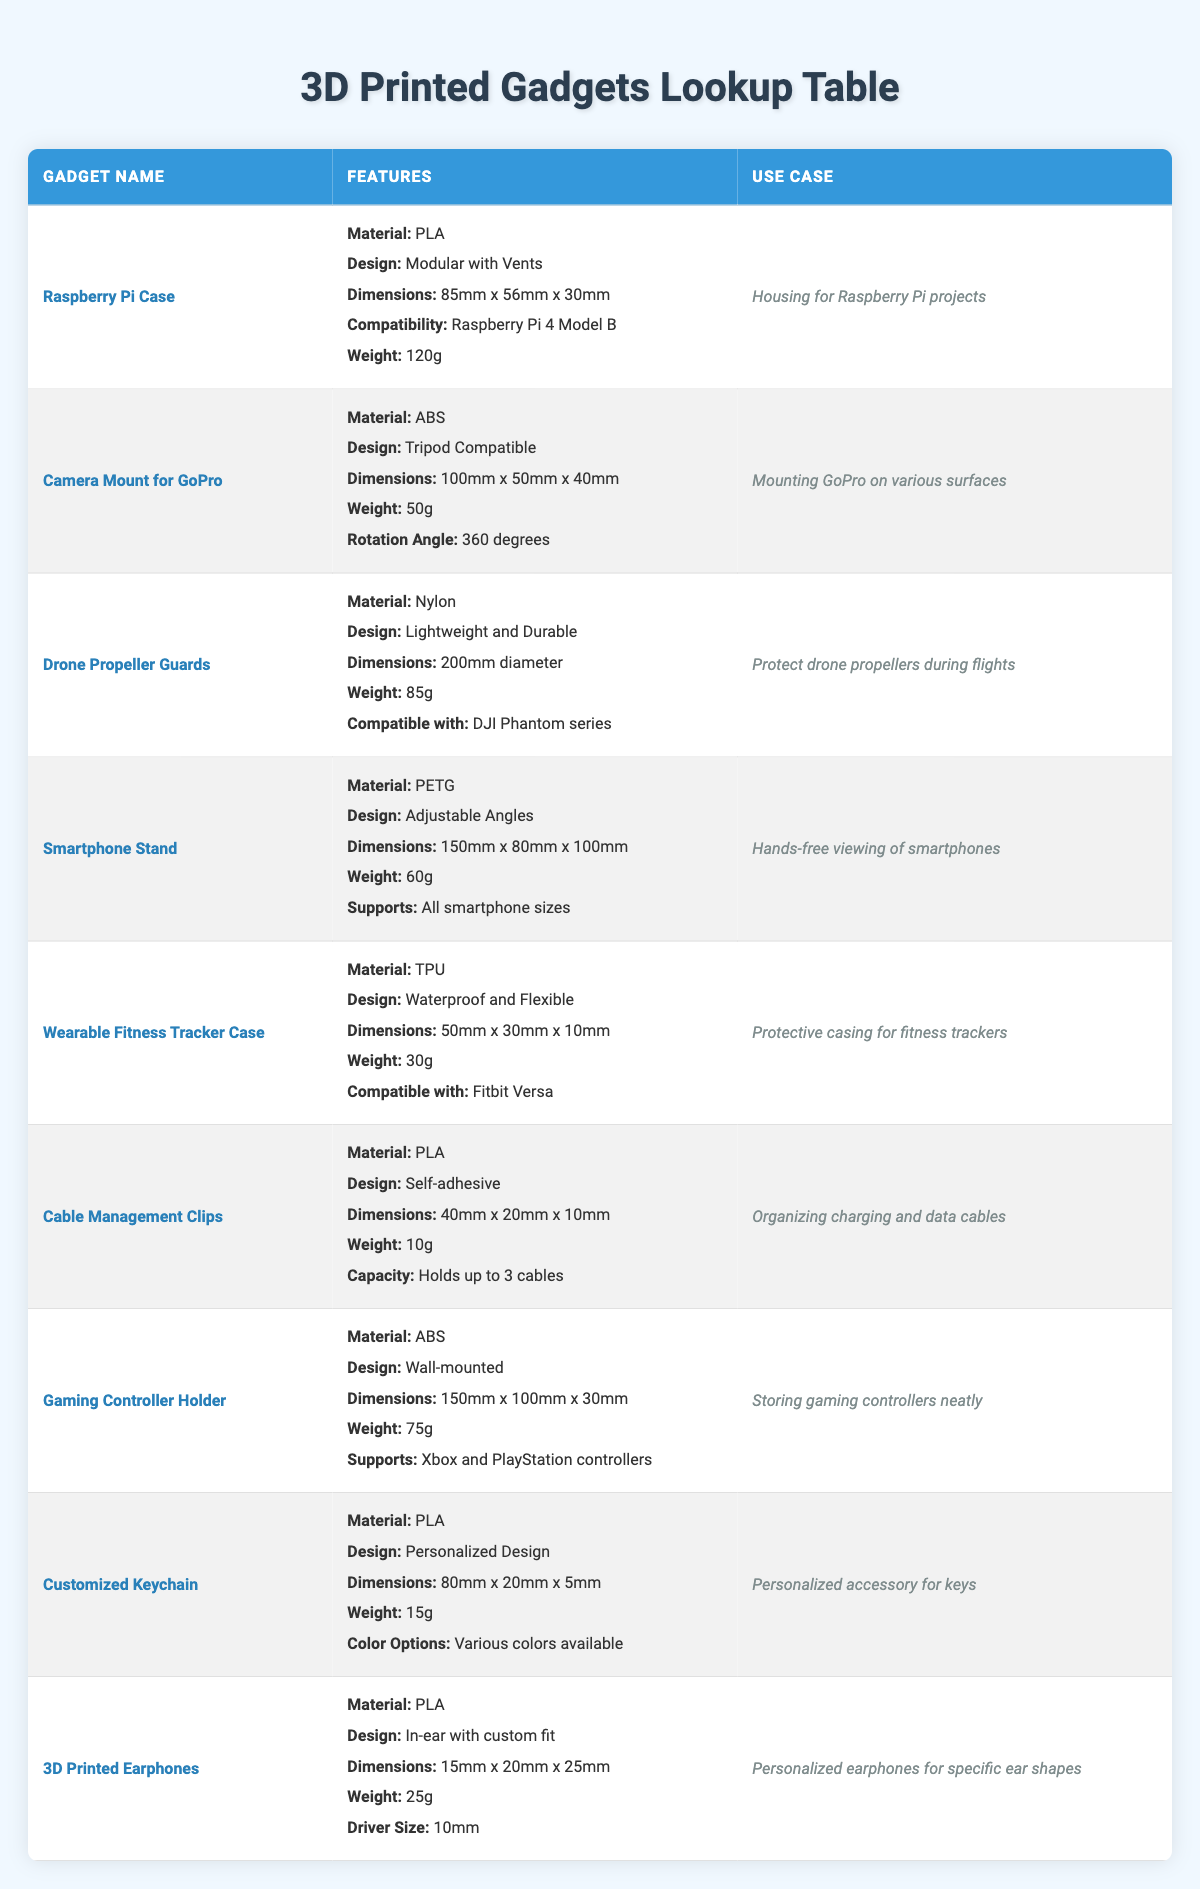What is the material used in the Raspberry Pi Case? The table indicates that the Raspberry Pi Case is made from PLA.
Answer: PLA How much does the Smartphone Stand weigh? Based on the table, the weight of the Smartphone Stand is given as 60g.
Answer: 60g Is the Gaming Controller Holder compatible with PlayStation controllers? Yes, the table shows that the Gaming Controller Holder supports Xbox and PlayStation controllers, confirming compatibility.
Answer: Yes What is the difference in weight between the Cable Management Clips and the Wearable Fitness Tracker Case? The weight of the Cable Management Clips is 10g, and the weight of the Wearable Fitness Tracker Case is 30g. The difference is 30g - 10g = 20g.
Answer: 20g Which gadget is designed for hands-free viewing of smartphones? According to the table, the Smartphone Stand specifically mentions its use case as hands-free viewing of smartphones.
Answer: Smartphone Stand What is the combined weight of the 3D Printed Earphones and Camera Mount for GoPro? The weight of the 3D Printed Earphones is 25g, and the Camera Mount for GoPro weighs 50g. Therefore, the combined weight is 25g + 50g = 75g.
Answer: 75g Does the Drone Propeller Guards have adjustable design features? No, the features listed for the Drone Propeller Guards do not mention adjustable design; instead, it is noted as lightweight and durable.
Answer: No What is the maximum cable capacity of the Cable Management Clips? The table lists that the Cable Management Clips can hold up to 3 cables, indicating its maximum capacity.
Answer: Holds up to 3 cables Which material is used for the Customized Keychain, and how does it compare to that of the 3D Printed Earphones? Both the Customized Keychain and 3D Printed Earphones are made from PLA; thus, the material is the same for both.
Answer: Same (PLA) 